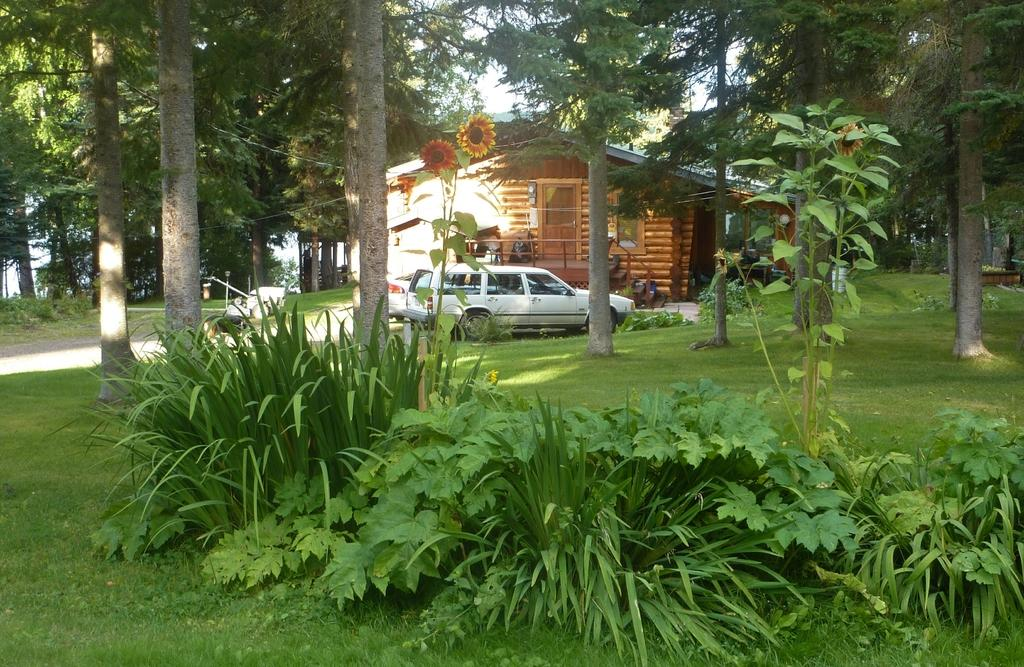What types of vegetation can be seen in the foreground of the image? There are plants and trees in the foreground of the image. What structures can be seen in the background of the image? There are buildings and trees in the background of the image. What type of ground cover is present in the image? There is grass on the ground in the image. What additional features can be seen in the image? There is a path and flowers in the image. What language is spoken by the flowers in the image? There is no indication that the flowers in the image are capable of speaking any language. What direction is the north located in the image? The image does not provide any information about the direction of north. 